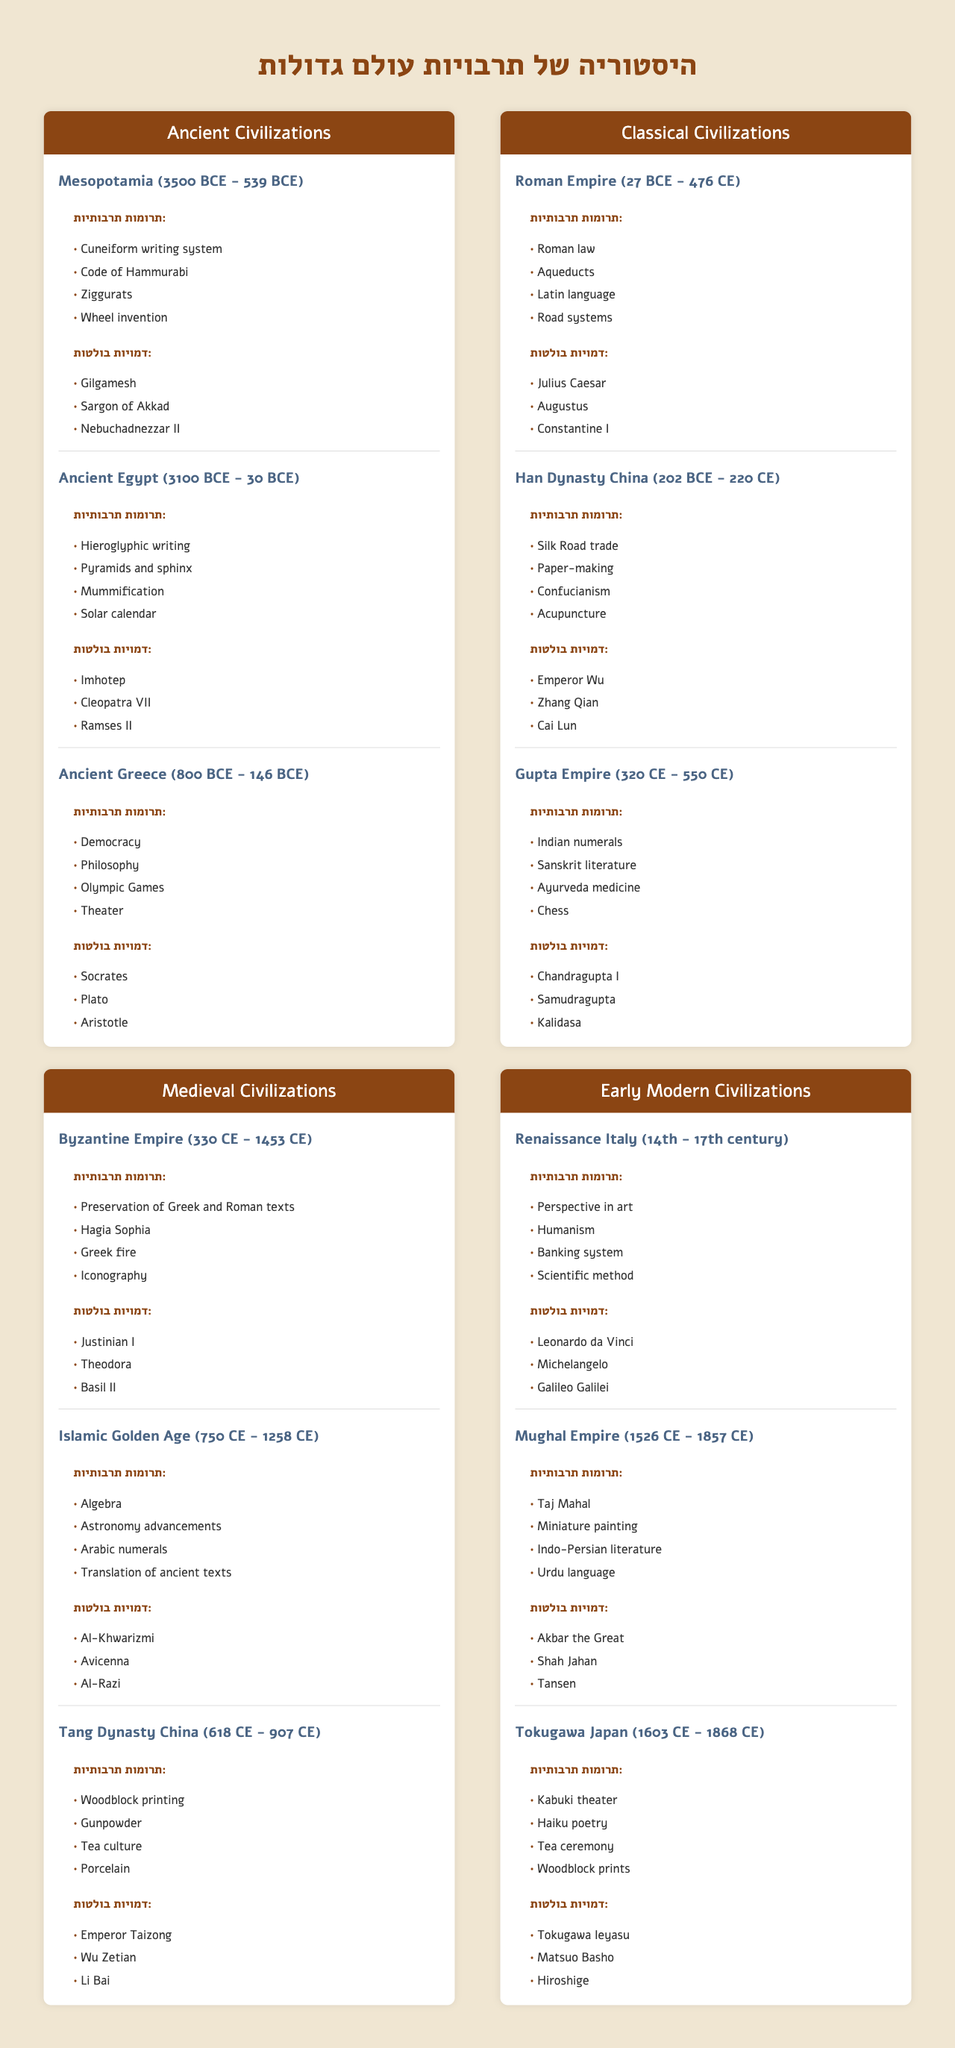What are the cultural contributions of Ancient Greece? By looking at the section for Ancient Greece in the table, the cultural contributions listed are Democracy, Philosophy, Olympic Games, and Theater.
Answer: Democracy, Philosophy, Olympic Games, Theater Who was a notable figure from the Roman Empire? The Roman Empire section lists notable figures such as Julius Caesar, Augustus, and Constantine I.
Answer: Julius Caesar, Augustus, Constantine I Does the Ancient Egyptian civilization include the concept of mummification? Yes, the Cultural Contributions for Ancient Egypt specifically mentions mummification.
Answer: Yes How many notable figures are associated with the Han Dynasty China? The Han Dynasty China has three notable figures listed: Emperor Wu, Zhang Qian, and Cai Lun.
Answer: 3 What are the similarities in cultural contributions between the Byzantine Empire and the Islamic Golden Age? Both civilizations contributed to the preservation of knowledge: the Byzantine Empire preserved Greek and Roman texts, while the Islamic Golden Age facilitated the translation of ancient texts.
Answer: Knowledge preservation List the cultural contributions of the Mughal Empire and determine if any of them overlap with Renaissance Italy. The cultural contributions of the Mughal Empire are Taj Mahal, Miniature painting, Indo-Persian literature, and Urdu language. The Renaissance Italy contributions are separate, including Perspective in art, Humanism, Banking system, and Scientific method. There is no overlap between the two contributions.
Answer: No overlap Which civilization contributed the concept of gunpowder? The table shows that the Tang Dynasty China is credited with the cultural contribution of gunpowder.
Answer: Tang Dynasty China Which era has the most notable figures listed, and how many are there? The Medieval Civilizations era has 8 notable figures in total (3 from Byzantine Empire, 3 from Islamic Golden Age, and 3 from Tang Dynasty China), which sums to 9 in total.
Answer: Medieval Civilizations (9 figures) What is the difference in cultural contributions between the Gupta Empire and the Islamic Golden Age? The Gupta Empire's contributions include Indian numerals, Sanskrit literature, Ayurveda medicine, and Chess, while the Islamic Golden Age contributed Algebra, advancements in Astronomy, Arabic numerals, and translation of ancient texts. The difference lies in the specific themes: one focuses on mathematics and literature, and the other on scientific and numerical advancements.
Answer: Different themes between mathematics/literature and scientific advancements Which civilization was responsible for the introduction of the solar calendar, and what other contributions did they make? The Ancient Egyptians introduced the solar calendar, also contributing Hieroglyphic writing, Pyramids and sphinx, and Mummification.
Answer: Ancient Egypt; contributions: Hieroglyphic writing, Pyramids and sphinx, Mummification How many civilizations contributed to cultural advances in Asia according to the table? The table indicates three relevant civilizations: Han Dynasty China, Tang Dynasty China, and the Mughal Empire.
Answer: 3 